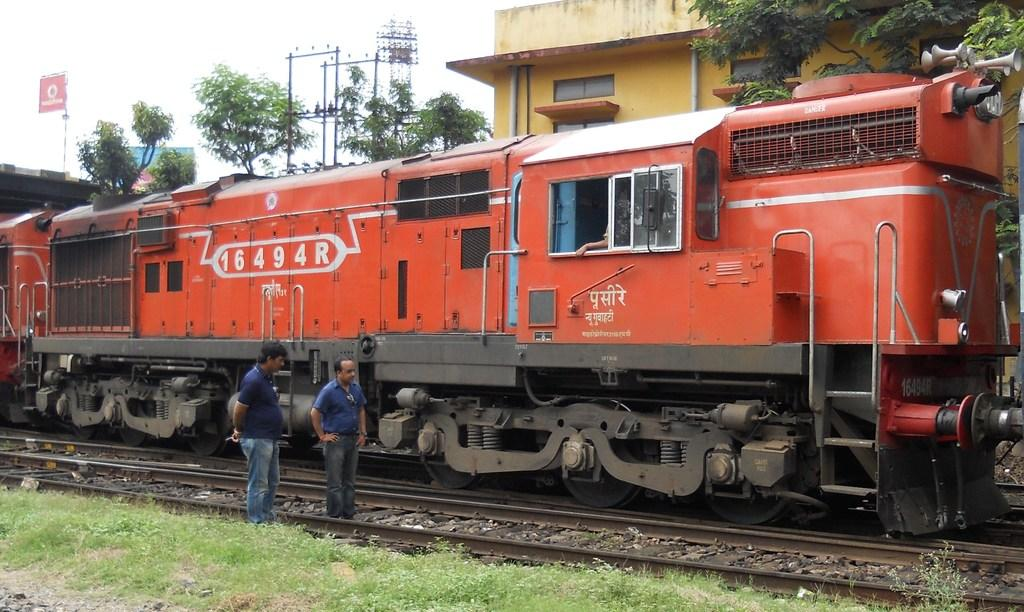Provide a one-sentence caption for the provided image. Two men are inspecting an orange train that says 16494R on the side. 